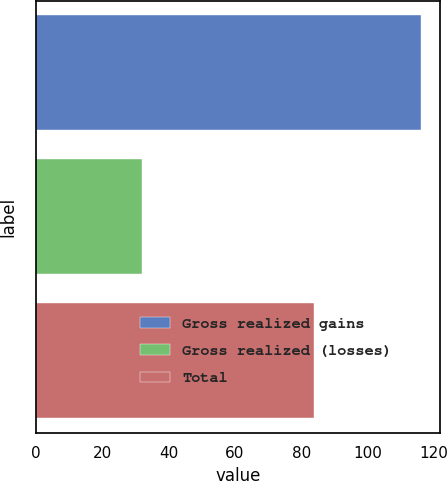Convert chart to OTSL. <chart><loc_0><loc_0><loc_500><loc_500><bar_chart><fcel>Gross realized gains<fcel>Gross realized (losses)<fcel>Total<nl><fcel>116<fcel>32<fcel>84<nl></chart> 